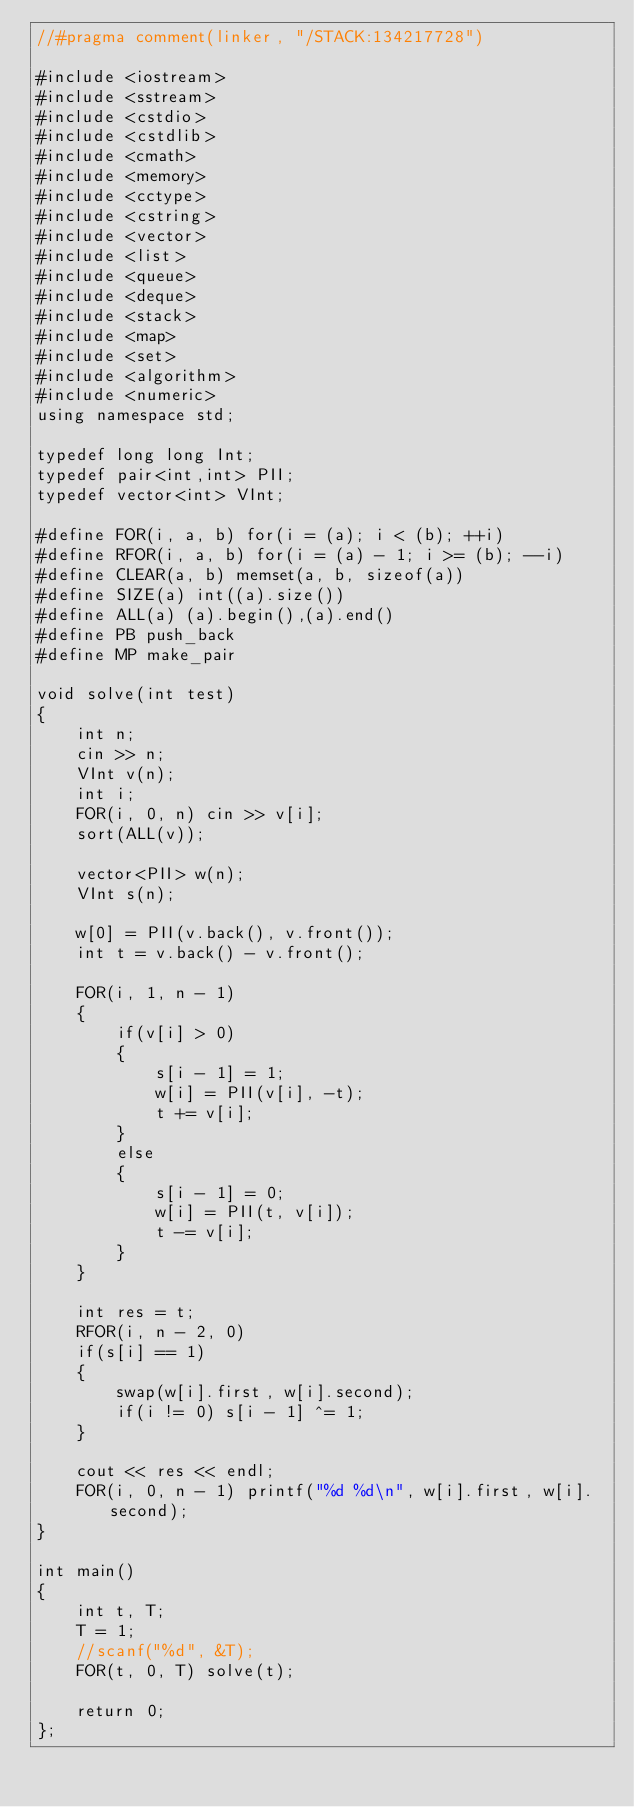Convert code to text. <code><loc_0><loc_0><loc_500><loc_500><_C++_>//#pragma comment(linker, "/STACK:134217728")

#include <iostream>
#include <sstream>
#include <cstdio>
#include <cstdlib>
#include <cmath>
#include <memory>
#include <cctype>
#include <cstring>
#include <vector>
#include <list>
#include <queue>
#include <deque>
#include <stack>
#include <map>
#include <set>
#include <algorithm>
#include <numeric>
using namespace std;

typedef long long Int;
typedef pair<int,int> PII;
typedef vector<int> VInt;

#define FOR(i, a, b) for(i = (a); i < (b); ++i)
#define RFOR(i, a, b) for(i = (a) - 1; i >= (b); --i)
#define CLEAR(a, b) memset(a, b, sizeof(a))
#define SIZE(a) int((a).size())
#define ALL(a) (a).begin(),(a).end()
#define PB push_back
#define MP make_pair

void solve(int test)
{
    int n;
    cin >> n;
    VInt v(n);
    int i;
    FOR(i, 0, n) cin >> v[i];
    sort(ALL(v));
    
    vector<PII> w(n);
    VInt s(n);
    
    w[0] = PII(v.back(), v.front());
    int t = v.back() - v.front();
    
    FOR(i, 1, n - 1)
    {
        if(v[i] > 0)
        {
            s[i - 1] = 1;
            w[i] = PII(v[i], -t);
            t += v[i];
        }
        else
        {
            s[i - 1] = 0;
            w[i] = PII(t, v[i]);
            t -= v[i];
        }
    }
    
    int res = t;
    RFOR(i, n - 2, 0)
    if(s[i] == 1)
    {
        swap(w[i].first, w[i].second);
        if(i != 0) s[i - 1] ^= 1;
    }
    
    cout << res << endl;
    FOR(i, 0, n - 1) printf("%d %d\n", w[i].first, w[i].second);
}

int main()
{
    int t, T;
    T = 1;
    //scanf("%d", &T);
    FOR(t, 0, T) solve(t);
    
    return 0;
};

</code> 